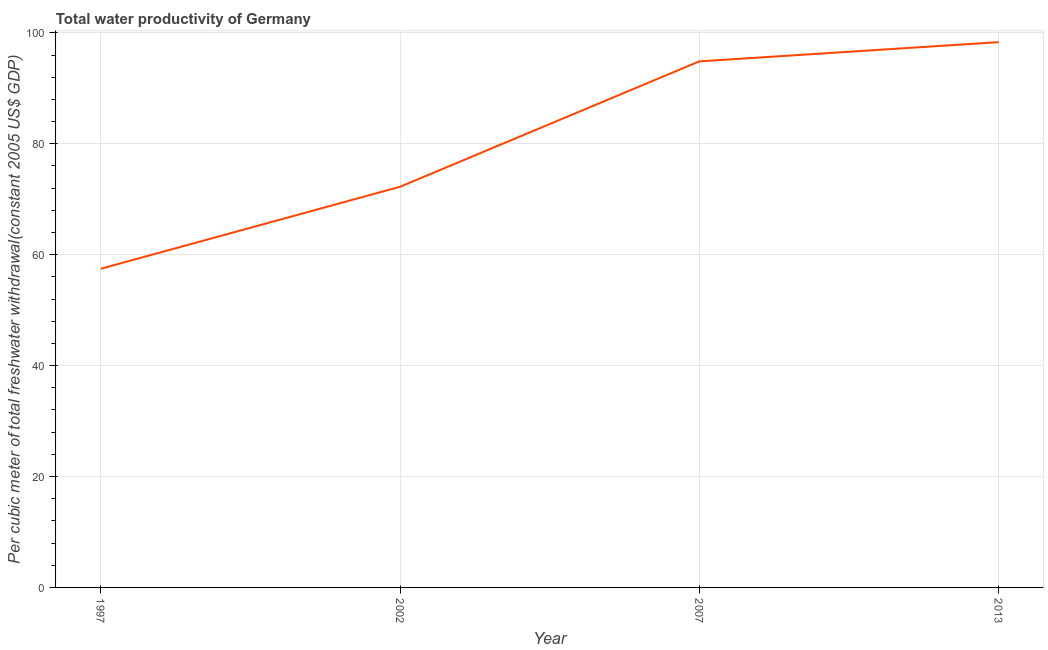What is the total water productivity in 2002?
Offer a terse response. 72.25. Across all years, what is the maximum total water productivity?
Ensure brevity in your answer.  98.33. Across all years, what is the minimum total water productivity?
Your response must be concise. 57.46. In which year was the total water productivity maximum?
Your answer should be compact. 2013. What is the sum of the total water productivity?
Your response must be concise. 322.9. What is the difference between the total water productivity in 1997 and 2002?
Your response must be concise. -14.79. What is the average total water productivity per year?
Your answer should be compact. 80.73. What is the median total water productivity?
Provide a short and direct response. 83.56. In how many years, is the total water productivity greater than 72 US$?
Give a very brief answer. 3. Do a majority of the years between 1997 and 2007 (inclusive) have total water productivity greater than 8 US$?
Offer a terse response. Yes. What is the ratio of the total water productivity in 1997 to that in 2007?
Provide a short and direct response. 0.61. Is the difference between the total water productivity in 2002 and 2007 greater than the difference between any two years?
Make the answer very short. No. What is the difference between the highest and the second highest total water productivity?
Your answer should be compact. 3.47. What is the difference between the highest and the lowest total water productivity?
Your answer should be compact. 40.87. In how many years, is the total water productivity greater than the average total water productivity taken over all years?
Offer a very short reply. 2. Does the total water productivity monotonically increase over the years?
Provide a succinct answer. Yes. How many years are there in the graph?
Offer a terse response. 4. Are the values on the major ticks of Y-axis written in scientific E-notation?
Offer a very short reply. No. Does the graph contain any zero values?
Offer a very short reply. No. What is the title of the graph?
Give a very brief answer. Total water productivity of Germany. What is the label or title of the Y-axis?
Offer a terse response. Per cubic meter of total freshwater withdrawal(constant 2005 US$ GDP). What is the Per cubic meter of total freshwater withdrawal(constant 2005 US$ GDP) in 1997?
Keep it short and to the point. 57.46. What is the Per cubic meter of total freshwater withdrawal(constant 2005 US$ GDP) in 2002?
Provide a short and direct response. 72.25. What is the Per cubic meter of total freshwater withdrawal(constant 2005 US$ GDP) in 2007?
Your answer should be very brief. 94.86. What is the Per cubic meter of total freshwater withdrawal(constant 2005 US$ GDP) of 2013?
Offer a terse response. 98.33. What is the difference between the Per cubic meter of total freshwater withdrawal(constant 2005 US$ GDP) in 1997 and 2002?
Ensure brevity in your answer.  -14.79. What is the difference between the Per cubic meter of total freshwater withdrawal(constant 2005 US$ GDP) in 1997 and 2007?
Make the answer very short. -37.4. What is the difference between the Per cubic meter of total freshwater withdrawal(constant 2005 US$ GDP) in 1997 and 2013?
Provide a succinct answer. -40.87. What is the difference between the Per cubic meter of total freshwater withdrawal(constant 2005 US$ GDP) in 2002 and 2007?
Provide a succinct answer. -22.61. What is the difference between the Per cubic meter of total freshwater withdrawal(constant 2005 US$ GDP) in 2002 and 2013?
Make the answer very short. -26.08. What is the difference between the Per cubic meter of total freshwater withdrawal(constant 2005 US$ GDP) in 2007 and 2013?
Keep it short and to the point. -3.47. What is the ratio of the Per cubic meter of total freshwater withdrawal(constant 2005 US$ GDP) in 1997 to that in 2002?
Offer a terse response. 0.8. What is the ratio of the Per cubic meter of total freshwater withdrawal(constant 2005 US$ GDP) in 1997 to that in 2007?
Make the answer very short. 0.61. What is the ratio of the Per cubic meter of total freshwater withdrawal(constant 2005 US$ GDP) in 1997 to that in 2013?
Make the answer very short. 0.58. What is the ratio of the Per cubic meter of total freshwater withdrawal(constant 2005 US$ GDP) in 2002 to that in 2007?
Your answer should be very brief. 0.76. What is the ratio of the Per cubic meter of total freshwater withdrawal(constant 2005 US$ GDP) in 2002 to that in 2013?
Offer a very short reply. 0.73. What is the ratio of the Per cubic meter of total freshwater withdrawal(constant 2005 US$ GDP) in 2007 to that in 2013?
Provide a short and direct response. 0.96. 